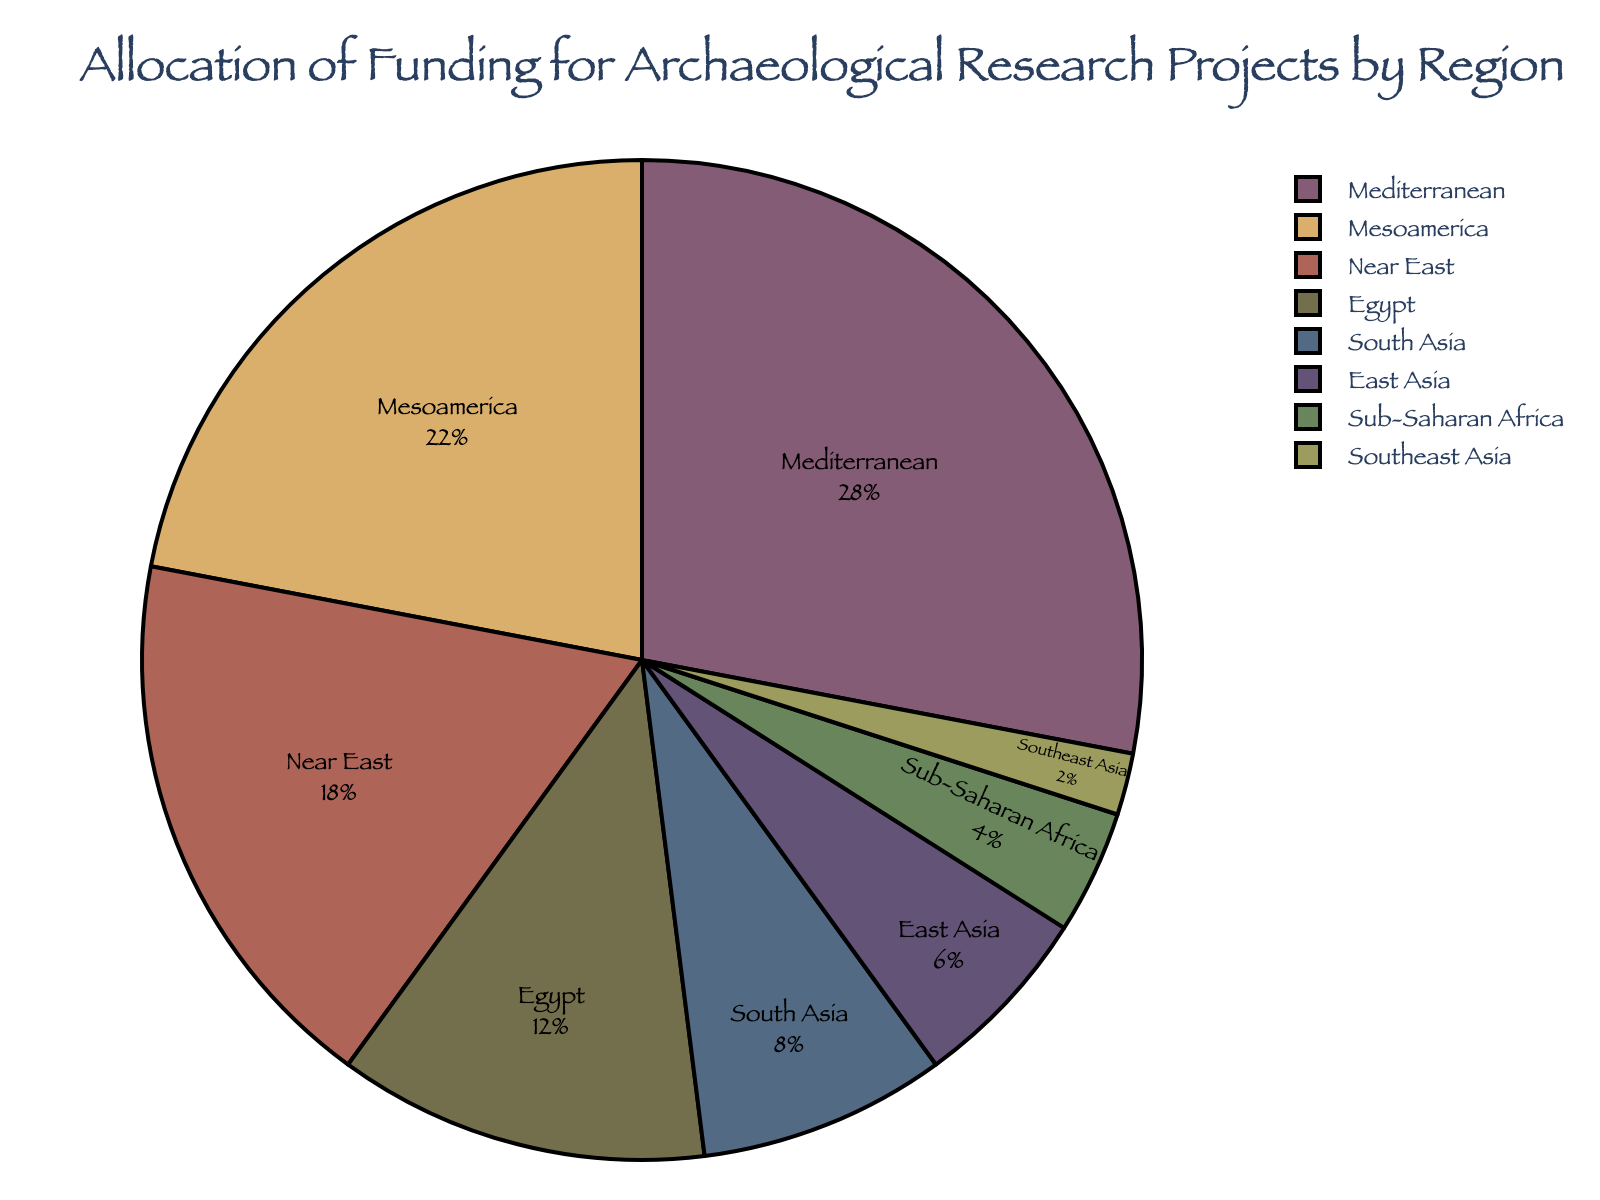What region receives the highest percentage of funding? The region with the largest slice of the pie chart is the Mediterranean region, which is clearly labeled and occupies the largest portion of the chart.
Answer: Mediterranean Which two regions receive the smallest percentages of funding? The smallest slices of the pie chart are labeled as Southeast Asia and Sub-Saharan Africa, which are the two regions with the least funding.
Answer: Southeast Asia and Sub-Saharan Africa What is the combined percentage of funding for the Mediterranean and Mesoamerica regions? Adding the percentages for the Mediterranean (28%) and Mesoamerica (22%) regions gives a total of 28 + 22 = 50%.
Answer: 50% How much more funding percentage does the Mediterranean region receive compared to East Asia? The Mediterranean region receives 28% of funding, while East Asia receives 6%. The difference is 28 - 6 = 22%.
Answer: 22% Which region receives twice as much funding as East Asia? East Asia receives 6%, and we need to find a region that receives twice this amount, which is 2 * 6 = 12%. According to the chart, Egypt receives 12%.
Answer: Egypt What is the total percentage of funding allocated to Near East, Egypt, and South Asia? Adding the percentages for Near East (18%), Egypt (12%), and South Asia (8%) gives a total of 18 + 12 + 8 = 38%.
Answer: 38% How does the percentage of funding for Sub-Saharan Africa compare to Egypt? Sub-Saharan Africa receives 4%, while Egypt receives 12%. Therefore, Sub-Saharan Africa receives less funding than Egypt.
Answer: Less Which region receives more funding: South Asia or East Asia? The pie chart shows that South Asia receives 8%, and East Asia receives 6%. South Asia receives more funding than East Asia.
Answer: South Asia What proportion of the total funding is allocated to the Near East region? The Near East region's funding is 18%, which can be seen as its slice of the pie chart.
Answer: 18% If funding for the Mediterranean region was increased by 7%, what would the new percentage be? The current funding for the Mediterranean is 28%. Increasing it by 7% results in 28 + 7 = 35%.
Answer: 35% 